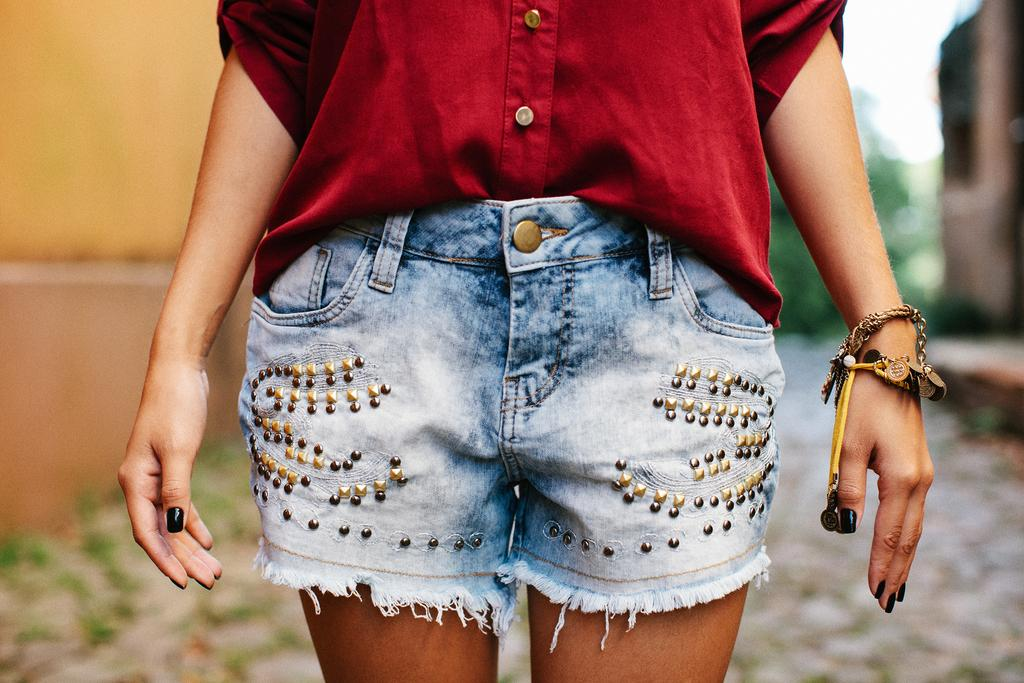What is the main subject of the image? There is a lady standing in the center of the image. What is the lady wearing in the image? The lady is wearing a red shirt. What can be seen in the background of the image? There is a wall and trees in the background of the image. What type of coast can be seen in the image? There is no coast visible in the image; it features a lady standing in front of a wall and trees. Is there a coil of rope present in the image? There is no coil of rope present in the image. 